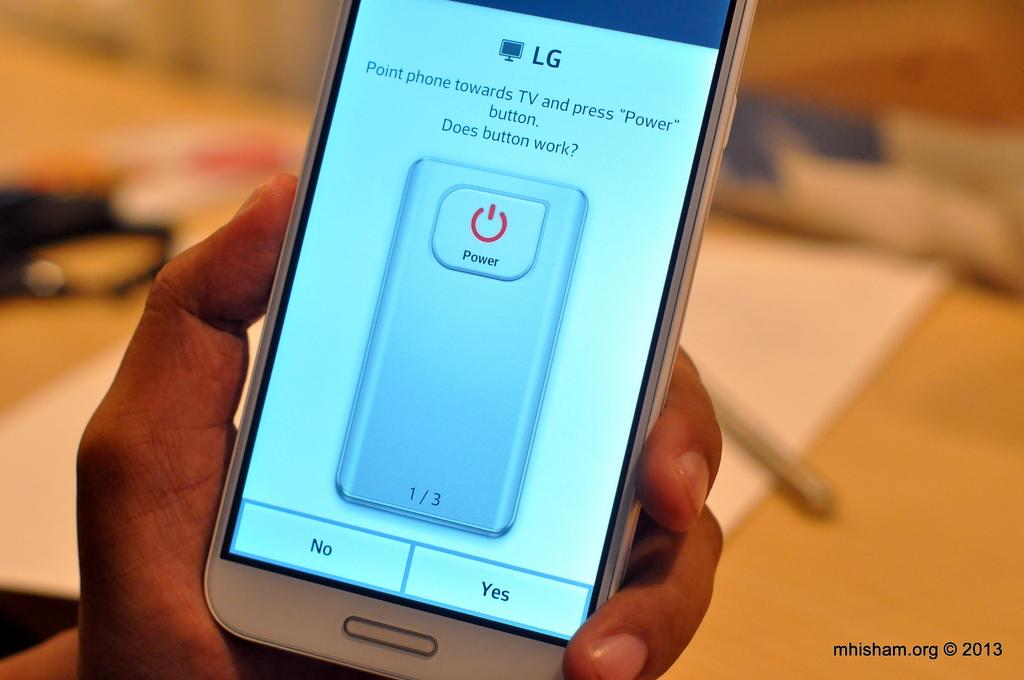<image>
Create a compact narrative representing the image presented. a Lg phone that says point towards tv does button work 